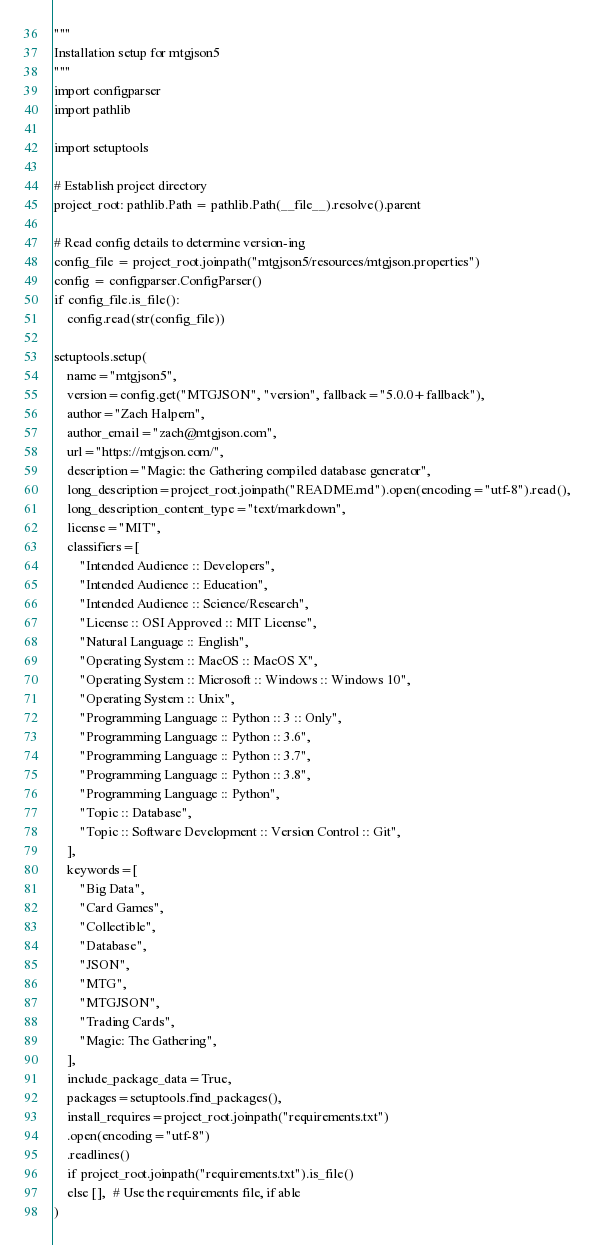Convert code to text. <code><loc_0><loc_0><loc_500><loc_500><_Python_>"""
Installation setup for mtgjson5
"""
import configparser
import pathlib

import setuptools

# Establish project directory
project_root: pathlib.Path = pathlib.Path(__file__).resolve().parent

# Read config details to determine version-ing
config_file = project_root.joinpath("mtgjson5/resources/mtgjson.properties")
config = configparser.ConfigParser()
if config_file.is_file():
    config.read(str(config_file))

setuptools.setup(
    name="mtgjson5",
    version=config.get("MTGJSON", "version", fallback="5.0.0+fallback"),
    author="Zach Halpern",
    author_email="zach@mtgjson.com",
    url="https://mtgjson.com/",
    description="Magic: the Gathering compiled database generator",
    long_description=project_root.joinpath("README.md").open(encoding="utf-8").read(),
    long_description_content_type="text/markdown",
    license="MIT",
    classifiers=[
        "Intended Audience :: Developers",
        "Intended Audience :: Education",
        "Intended Audience :: Science/Research",
        "License :: OSI Approved :: MIT License",
        "Natural Language :: English",
        "Operating System :: MacOS :: MacOS X",
        "Operating System :: Microsoft :: Windows :: Windows 10",
        "Operating System :: Unix",
        "Programming Language :: Python :: 3 :: Only",
        "Programming Language :: Python :: 3.6",
        "Programming Language :: Python :: 3.7",
        "Programming Language :: Python :: 3.8",
        "Programming Language :: Python",
        "Topic :: Database",
        "Topic :: Software Development :: Version Control :: Git",
    ],
    keywords=[
        "Big Data",
        "Card Games",
        "Collectible",
        "Database",
        "JSON",
        "MTG",
        "MTGJSON",
        "Trading Cards",
        "Magic: The Gathering",
    ],
    include_package_data=True,
    packages=setuptools.find_packages(),
    install_requires=project_root.joinpath("requirements.txt")
    .open(encoding="utf-8")
    .readlines()
    if project_root.joinpath("requirements.txt").is_file()
    else [],  # Use the requirements file, if able
)
</code> 